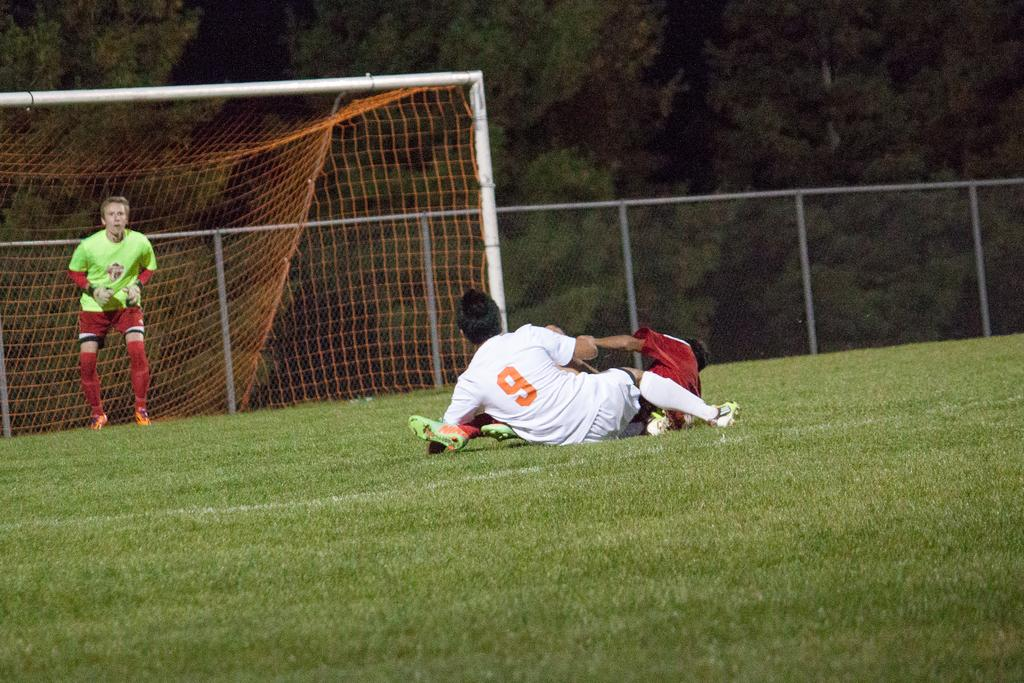<image>
Describe the image concisely. A goalie wearing a green jersey and two players including number 9 on the ground. 